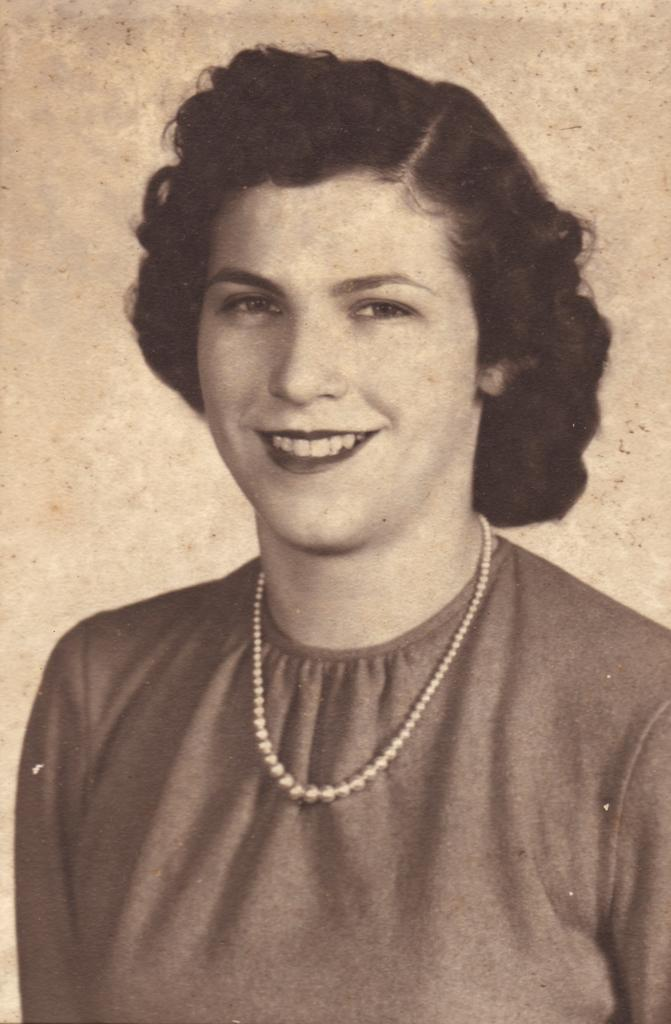Who is the main subject in the foreground of the image? There is a woman in the foreground of the image. What type of motion is the woman's face making in the image? There is no indication of motion or facial expressions in the image, as it only shows a woman in the foreground. 